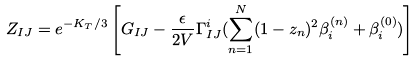Convert formula to latex. <formula><loc_0><loc_0><loc_500><loc_500>Z _ { I J } = e ^ { - K _ { T } / 3 } \left [ G _ { I J } - \frac { \epsilon } { 2 V } { \Gamma } ^ { i } _ { I J } ( \sum ^ { N } _ { n = 1 } ( 1 - z _ { n } ) ^ { 2 } \beta ^ { ( n ) } _ { i } + \beta ^ { ( 0 ) } _ { i } ) \right ]</formula> 